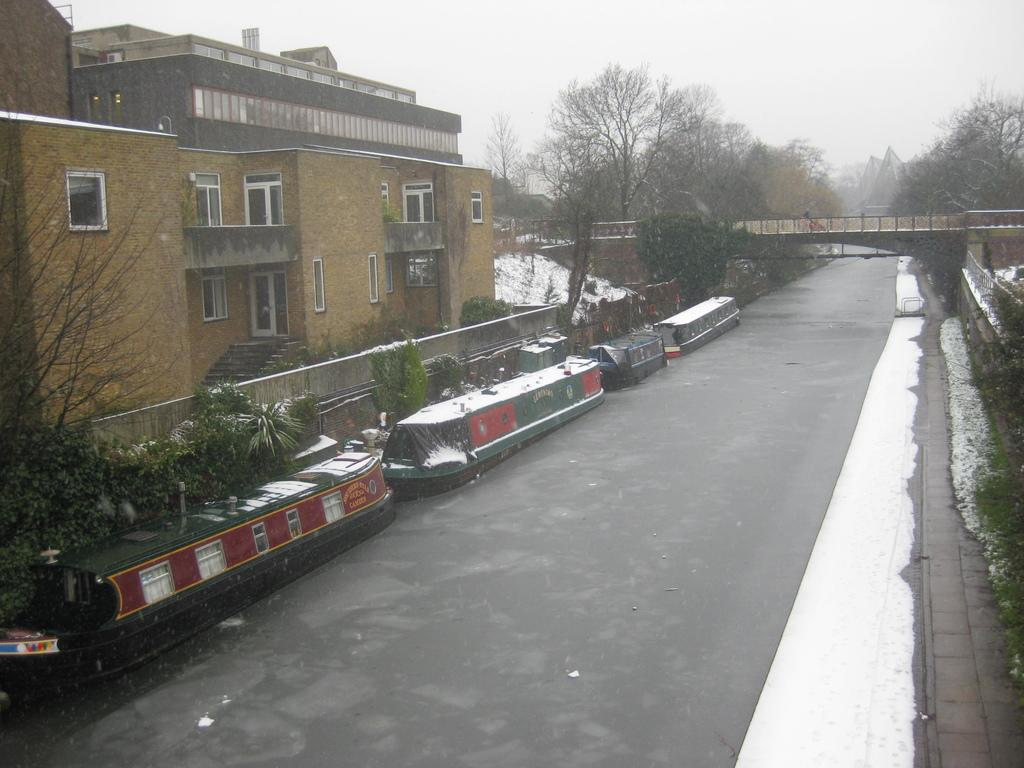Where was the image taken? The image was clicked outside. What structure can be seen on the left side of the image? There is a building on the left side of the image. What type of vegetation is in the middle of the image? There are trees in the middle of the image. What is visible at the top of the image? The sky is visible at the top of the image. What type of straw is hanging from the building in the image? There is no straw hanging from the building in the image. Is there a vest visible on any person in the image? There are no people visible in the image, so it is impossible to determine if a vest is present. Where is the faucet located in the image? There is no faucet present in the image. 